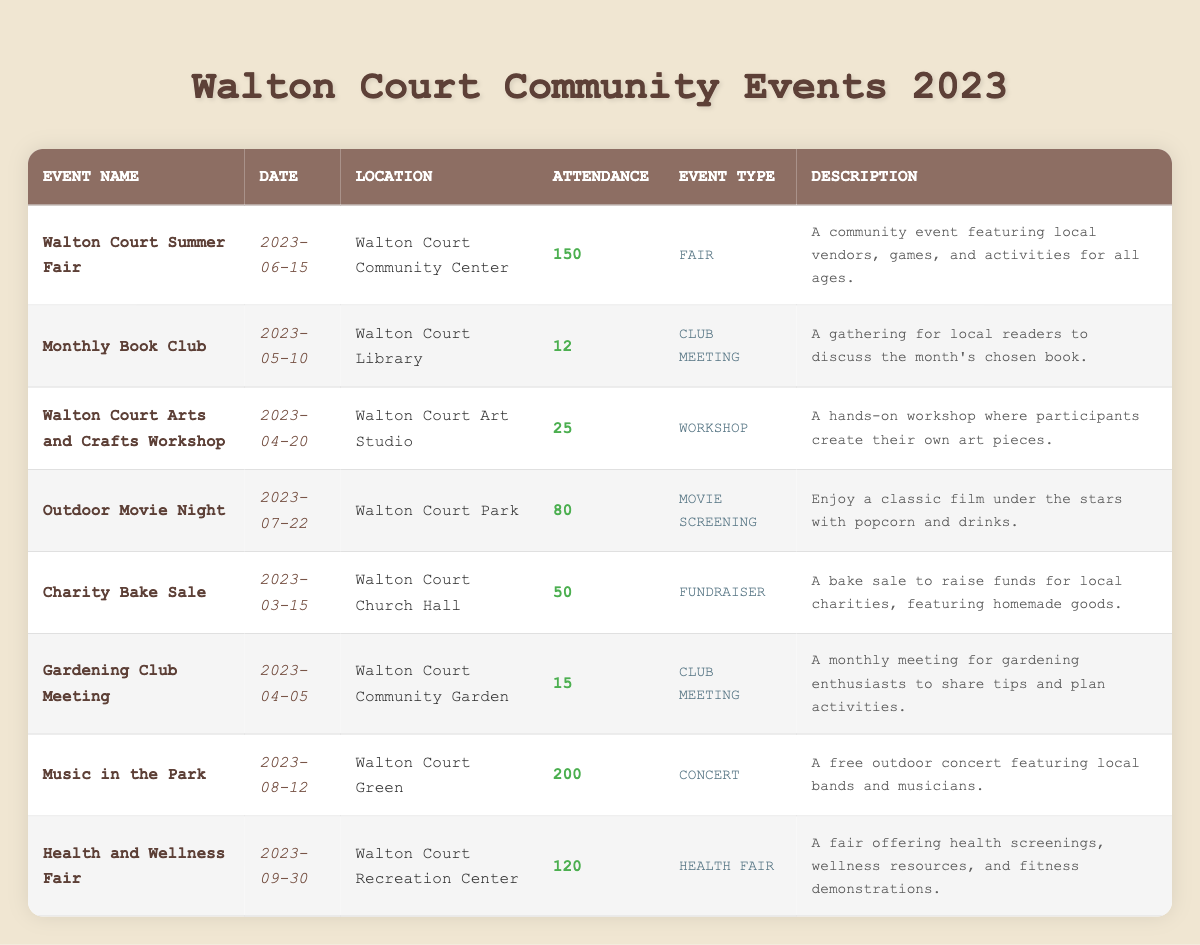What was the attendance for the Walton Court Summer Fair? The attendance for the Walton Court Summer Fair is listed directly in the table under the "Attendance" column for that event, which shows the value of 150.
Answer: 150 How many people attended the Monthly Book Club? The table specifies that the attendance for the Monthly Book Club is recorded as 12 in the "Attendance" column.
Answer: 12 What is the total attendance across all events listed? To find the total attendance, I need to sum the attendance figures from all events: 150 + 12 + 25 + 80 + 50 + 15 + 200 + 120 = 652.
Answer: 652 Did the Outdoor Movie Night have more than 100 attendees? I can check the attendance for the Outdoor Movie Night, which is listed as 80 in the table. Since 80 is not more than 100, the answer is no.
Answer: No Which event had the highest attendance, and what was that number? By comparing the attendance figures of all events, Music in the Park has the highest attendance at 200.
Answer: Music in the Park, 200 How many events were held at the Walton Court Community Center? I can find the location in the table for each event, and it shows that there is one event, the Walton Court Summer Fair, listed at that location.
Answer: 1 What was the average attendance for the club meetings? There are two club meetings: the Monthly Book Club (12) and the Gardening Club Meeting (15). Their total attendance is 12 + 15 = 27. Since there are 2 events, the average attendance is 27 / 2 = 13.5.
Answer: 13.5 Is the attendance for the Health and Wellness Fair greater than 100? The attendance for the Health and Wellness Fair is listed as 120 in the table. Since 120 is greater than 100, the answer is yes.
Answer: Yes How many events took place in April 2023? Scanning through the dates in the table, there are two events in April: the Gardening Club Meeting on April 5 and the Arts and Crafts Workshop on April 20. Thus, there are two events in total.
Answer: 2 